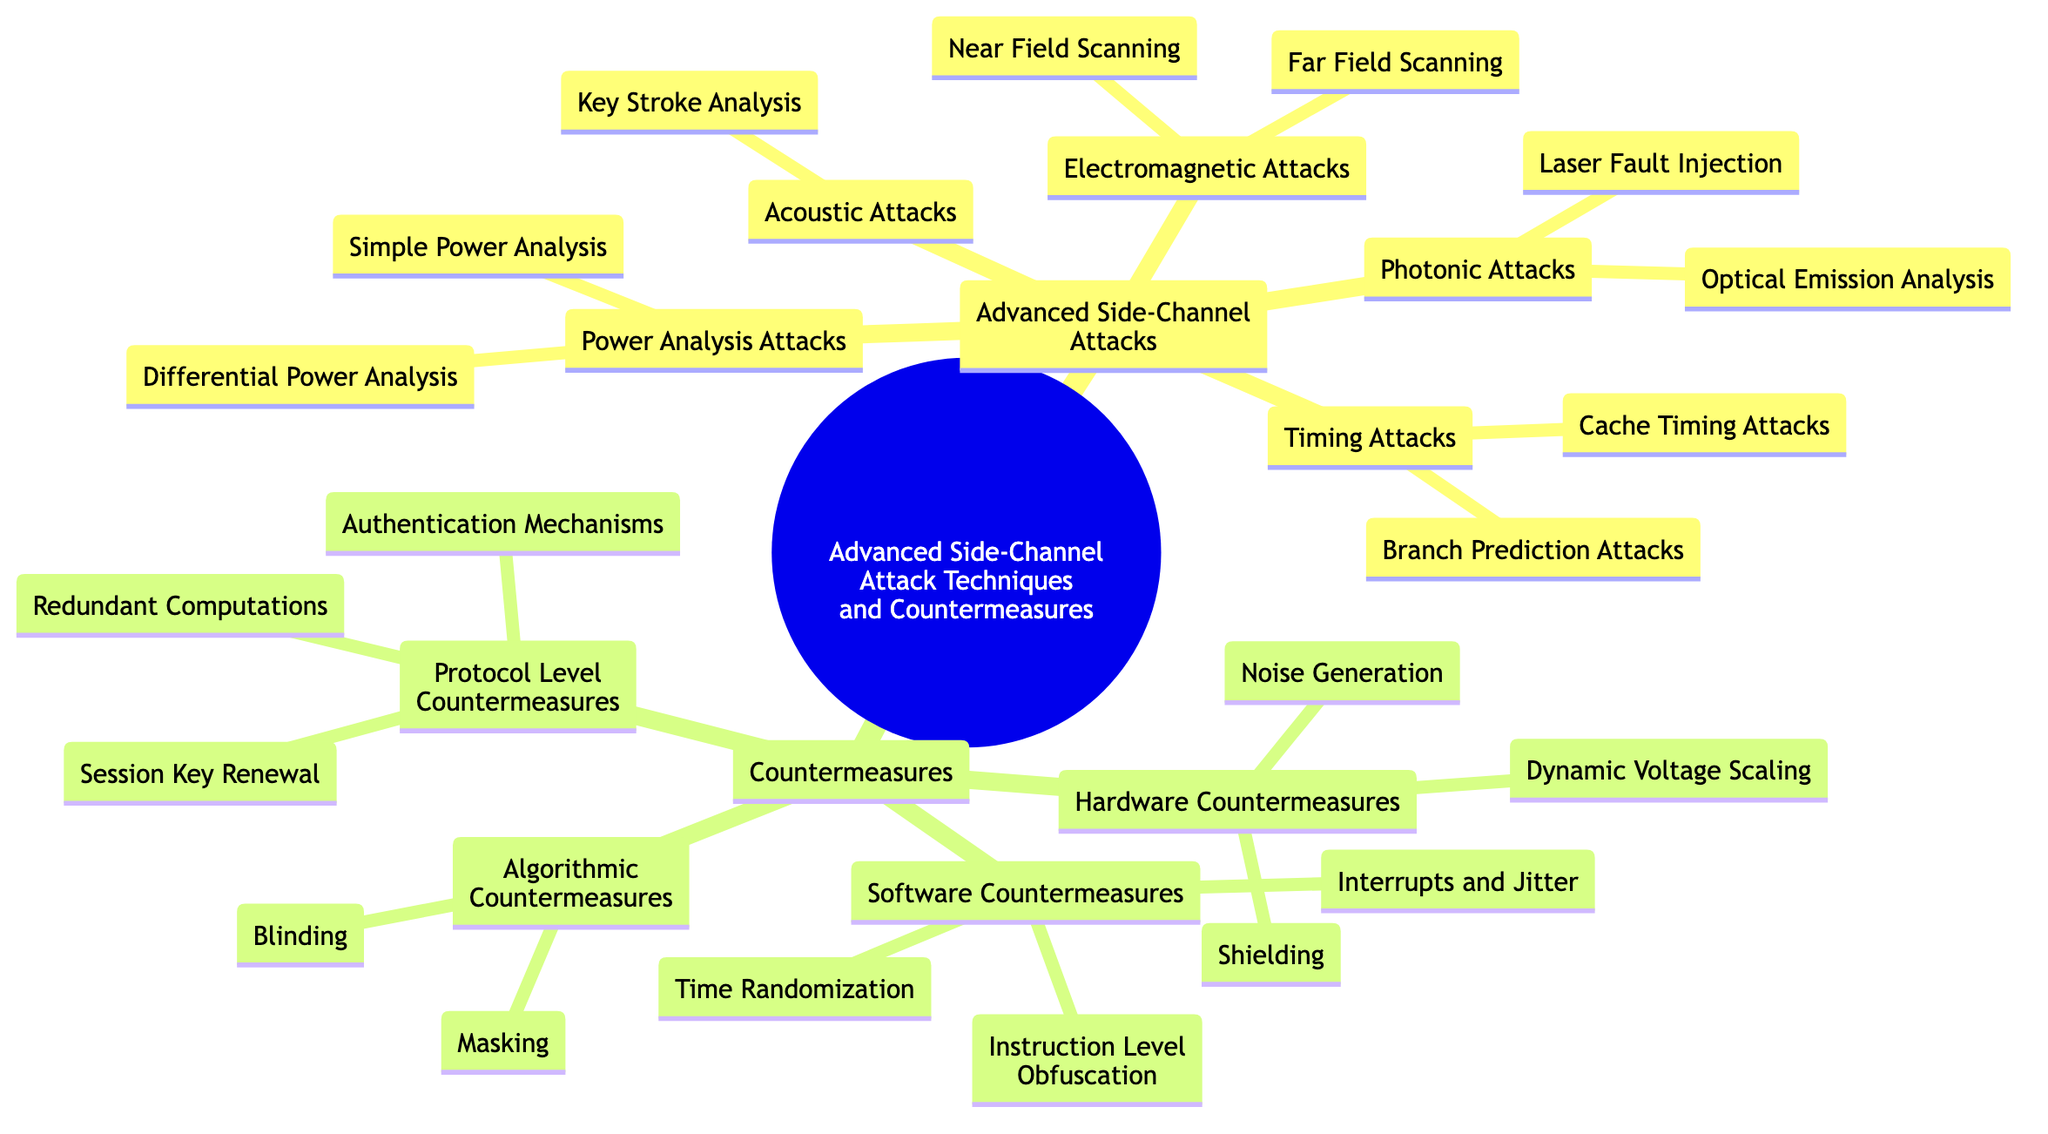What are the two categories of attacks listed in the diagram? The diagram categorizes advanced side-channel attacks into two main types: "Advanced Side-Channel Attacks" and "Countermeasures."
Answer: Advanced Side-Channel Attacks, Countermeasures How many types of Power Analysis Attacks are there? Under the "Power Analysis Attacks" node in the diagram, there are two types listed: "Simple Power Analysis" and "Differential Power Analysis." Thus, the total is two.
Answer: 2 Which type of countermeasure involves "Noise Generation"? "Noise Generation" is categorized under "Hardware Countermeasures," which is part of the broader "Countermeasures" category in the diagram.
Answer: Hardware Countermeasures What attack method falls under the category of Photonic Attacks? The "Laser Fault Injection" and "Optical Emission Analysis" methods are listed under the "Photonic Attacks" category in the diagram.
Answer: Laser Fault Injection, Optical Emission Analysis How many subtypes are under the Timing Attacks category? The "Timing Attacks" category contains two subtypes: "Cache Timing Attacks" and "Branch Prediction Attacks," making a total of two subtypes.
Answer: 2 Which countermeasure category includes "Session Key Renewal"? "Session Key Renewal" is included under "Protocol Level Countermeasures" in the diagram, which is one of the major countermeasure categories.
Answer: Protocol Level Countermeasures What is the relationship between "Differential Power Analysis" and "Power Analysis Attacks"? "Differential Power Analysis" is a subtype that falls directly under the broader category of "Power Analysis Attacks" in the diagram.
Answer: Subtype of Power Analysis Attacks What does the diagram suggest as a Software Countermeasure? The diagram lists several strategies under “Software Countermeasures,” including “Time Randomization,” which represents one of the suggested countermeasures.
Answer: Time Randomization 